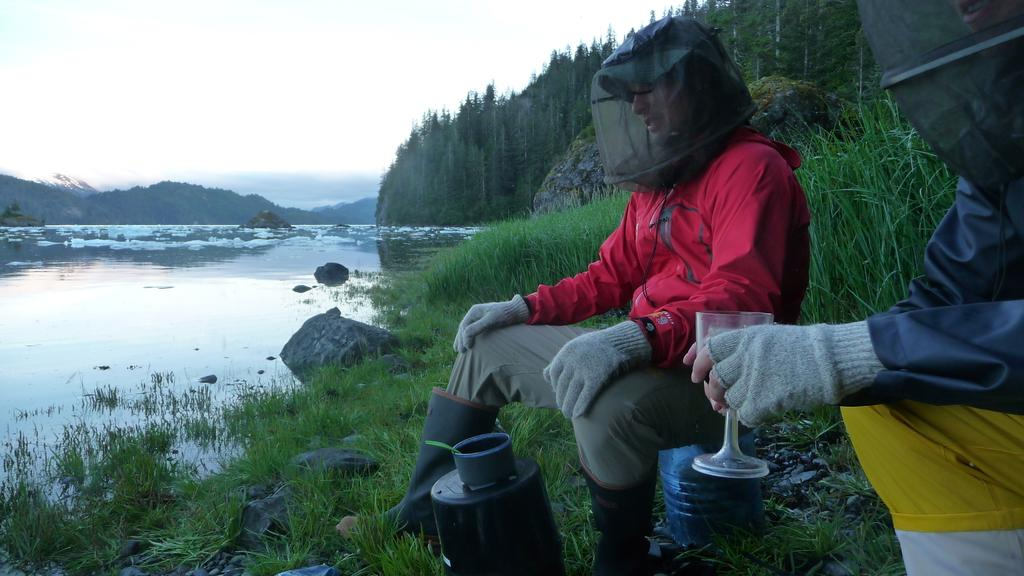How many people are in the image? There are two people in the image. What type of clothing or accessory can be seen in the image? Gloves are present in the image. What type of container is visible in the image? There is a glass in the image. What type of vegetation is visible in the image? Plants and trees are visible in the image. What type of natural feature is present in the image? Mountains are present in the image. What type of liquid is visible in the image? There is water in the image. What type of geological feature is present in the image? Rocks are present in the image. What is visible in the background of the image? The sky is visible in the background of the image. What type of button can be seen on the eye of the person in the image? There is no button or eye visible in the image; it features two people, gloves, a glass, plants, trees, mountains, water, rocks, and the sky. 